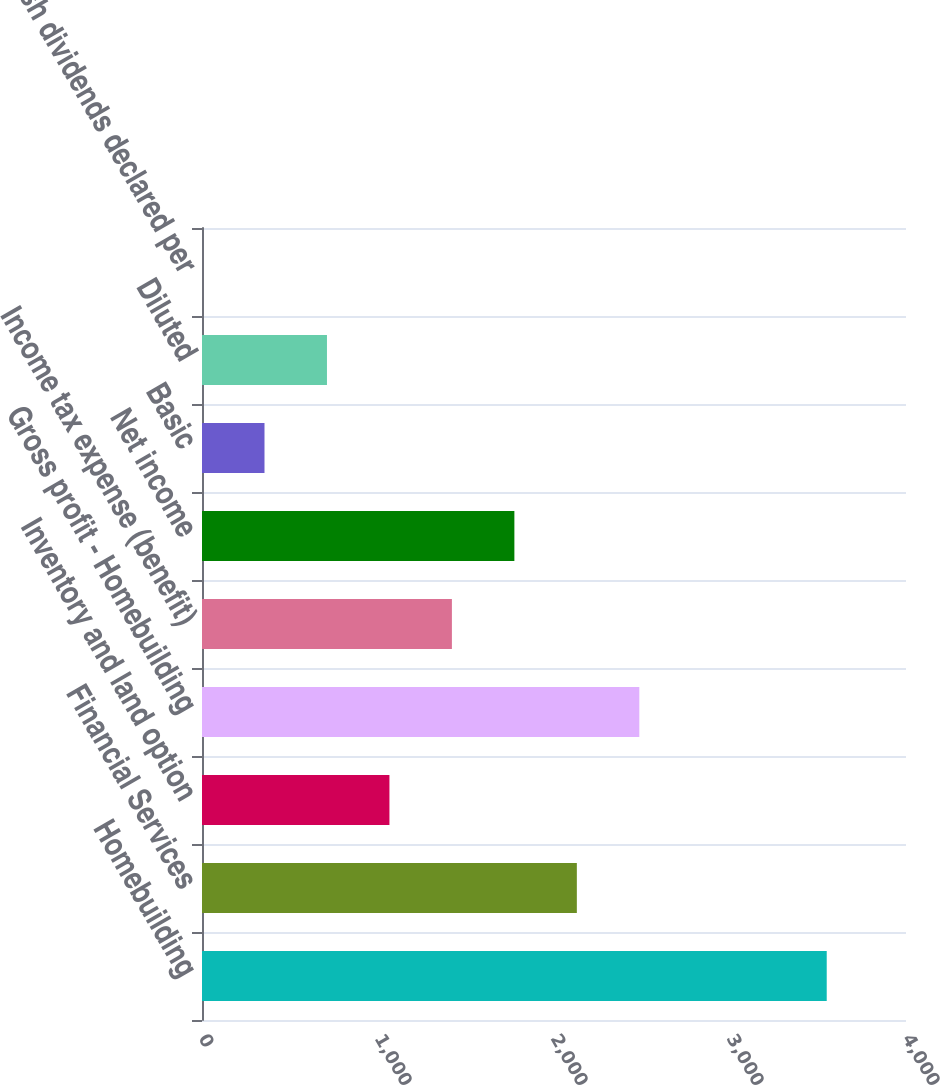Convert chart to OTSL. <chart><loc_0><loc_0><loc_500><loc_500><bar_chart><fcel>Homebuilding<fcel>Financial Services<fcel>Inventory and land option<fcel>Gross profit - Homebuilding<fcel>Income tax expense (benefit)<fcel>Net income<fcel>Basic<fcel>Diluted<fcel>Cash dividends declared per<nl><fcel>3549.6<fcel>2129.8<fcel>1064.97<fcel>2484.75<fcel>1419.91<fcel>1774.86<fcel>355.09<fcel>710.03<fcel>0.15<nl></chart> 